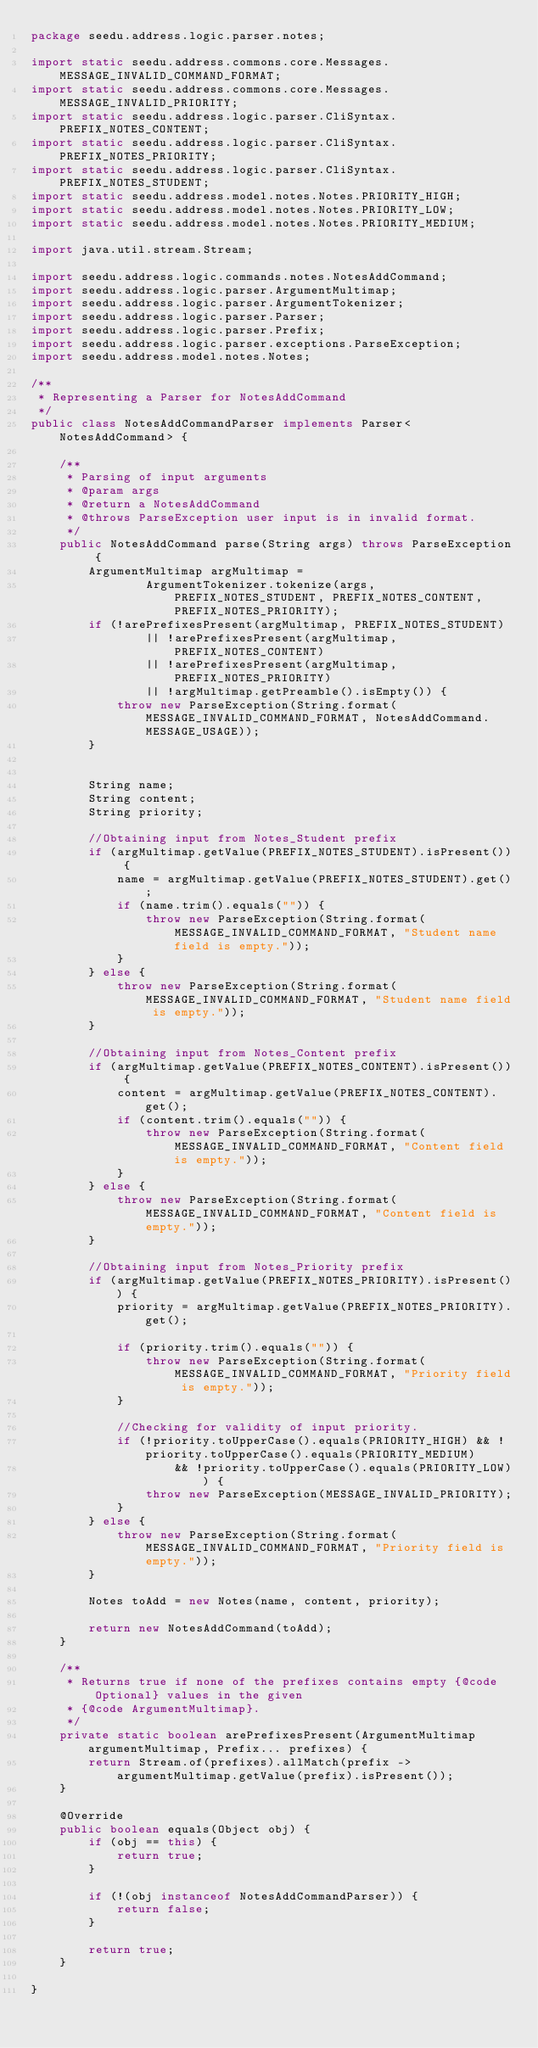Convert code to text. <code><loc_0><loc_0><loc_500><loc_500><_Java_>package seedu.address.logic.parser.notes;

import static seedu.address.commons.core.Messages.MESSAGE_INVALID_COMMAND_FORMAT;
import static seedu.address.commons.core.Messages.MESSAGE_INVALID_PRIORITY;
import static seedu.address.logic.parser.CliSyntax.PREFIX_NOTES_CONTENT;
import static seedu.address.logic.parser.CliSyntax.PREFIX_NOTES_PRIORITY;
import static seedu.address.logic.parser.CliSyntax.PREFIX_NOTES_STUDENT;
import static seedu.address.model.notes.Notes.PRIORITY_HIGH;
import static seedu.address.model.notes.Notes.PRIORITY_LOW;
import static seedu.address.model.notes.Notes.PRIORITY_MEDIUM;

import java.util.stream.Stream;

import seedu.address.logic.commands.notes.NotesAddCommand;
import seedu.address.logic.parser.ArgumentMultimap;
import seedu.address.logic.parser.ArgumentTokenizer;
import seedu.address.logic.parser.Parser;
import seedu.address.logic.parser.Prefix;
import seedu.address.logic.parser.exceptions.ParseException;
import seedu.address.model.notes.Notes;

/**
 * Representing a Parser for NotesAddCommand
 */
public class NotesAddCommandParser implements Parser<NotesAddCommand> {

    /**
     * Parsing of input arguments
     * @param args
     * @return a NotesAddCommand
     * @throws ParseException user input is in invalid format.
     */
    public NotesAddCommand parse(String args) throws ParseException {
        ArgumentMultimap argMultimap =
                ArgumentTokenizer.tokenize(args, PREFIX_NOTES_STUDENT, PREFIX_NOTES_CONTENT, PREFIX_NOTES_PRIORITY);
        if (!arePrefixesPresent(argMultimap, PREFIX_NOTES_STUDENT)
                || !arePrefixesPresent(argMultimap, PREFIX_NOTES_CONTENT)
                || !arePrefixesPresent(argMultimap, PREFIX_NOTES_PRIORITY)
                || !argMultimap.getPreamble().isEmpty()) {
            throw new ParseException(String.format(MESSAGE_INVALID_COMMAND_FORMAT, NotesAddCommand.MESSAGE_USAGE));
        }


        String name;
        String content;
        String priority;

        //Obtaining input from Notes_Student prefix
        if (argMultimap.getValue(PREFIX_NOTES_STUDENT).isPresent()) {
            name = argMultimap.getValue(PREFIX_NOTES_STUDENT).get();
            if (name.trim().equals("")) {
                throw new ParseException(String.format(MESSAGE_INVALID_COMMAND_FORMAT, "Student name field is empty."));
            }
        } else {
            throw new ParseException(String.format(MESSAGE_INVALID_COMMAND_FORMAT, "Student name field is empty."));
        }

        //Obtaining input from Notes_Content prefix
        if (argMultimap.getValue(PREFIX_NOTES_CONTENT).isPresent()) {
            content = argMultimap.getValue(PREFIX_NOTES_CONTENT).get();
            if (content.trim().equals("")) {
                throw new ParseException(String.format(MESSAGE_INVALID_COMMAND_FORMAT, "Content field is empty."));
            }
        } else {
            throw new ParseException(String.format(MESSAGE_INVALID_COMMAND_FORMAT, "Content field is empty."));
        }

        //Obtaining input from Notes_Priority prefix
        if (argMultimap.getValue(PREFIX_NOTES_PRIORITY).isPresent()) {
            priority = argMultimap.getValue(PREFIX_NOTES_PRIORITY).get();

            if (priority.trim().equals("")) {
                throw new ParseException(String.format(MESSAGE_INVALID_COMMAND_FORMAT, "Priority field is empty."));
            }

            //Checking for validity of input priority.
            if (!priority.toUpperCase().equals(PRIORITY_HIGH) && !priority.toUpperCase().equals(PRIORITY_MEDIUM)
                    && !priority.toUpperCase().equals(PRIORITY_LOW)) {
                throw new ParseException(MESSAGE_INVALID_PRIORITY);
            }
        } else {
            throw new ParseException(String.format(MESSAGE_INVALID_COMMAND_FORMAT, "Priority field is empty."));
        }

        Notes toAdd = new Notes(name, content, priority);

        return new NotesAddCommand(toAdd);
    }

    /**
     * Returns true if none of the prefixes contains empty {@code Optional} values in the given
     * {@code ArgumentMultimap}.
     */
    private static boolean arePrefixesPresent(ArgumentMultimap argumentMultimap, Prefix... prefixes) {
        return Stream.of(prefixes).allMatch(prefix -> argumentMultimap.getValue(prefix).isPresent());
    }

    @Override
    public boolean equals(Object obj) {
        if (obj == this) {
            return true;
        }

        if (!(obj instanceof NotesAddCommandParser)) {
            return false;
        }

        return true;
    }

}

</code> 